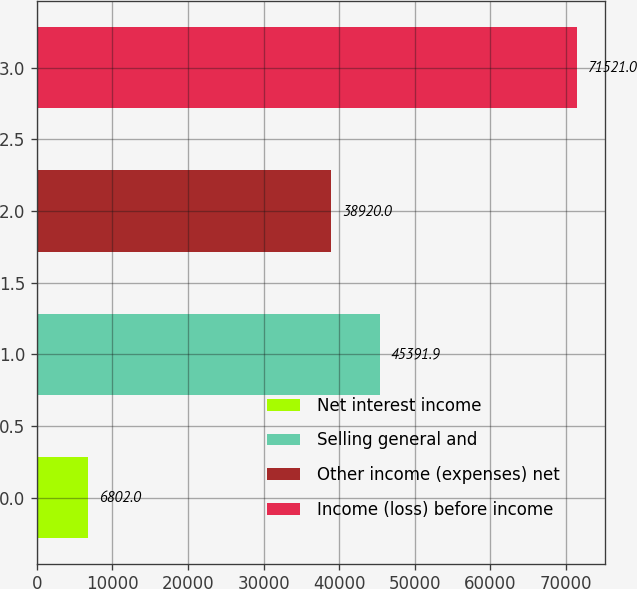Convert chart to OTSL. <chart><loc_0><loc_0><loc_500><loc_500><bar_chart><fcel>Net interest income<fcel>Selling general and<fcel>Other income (expenses) net<fcel>Income (loss) before income<nl><fcel>6802<fcel>45391.9<fcel>38920<fcel>71521<nl></chart> 